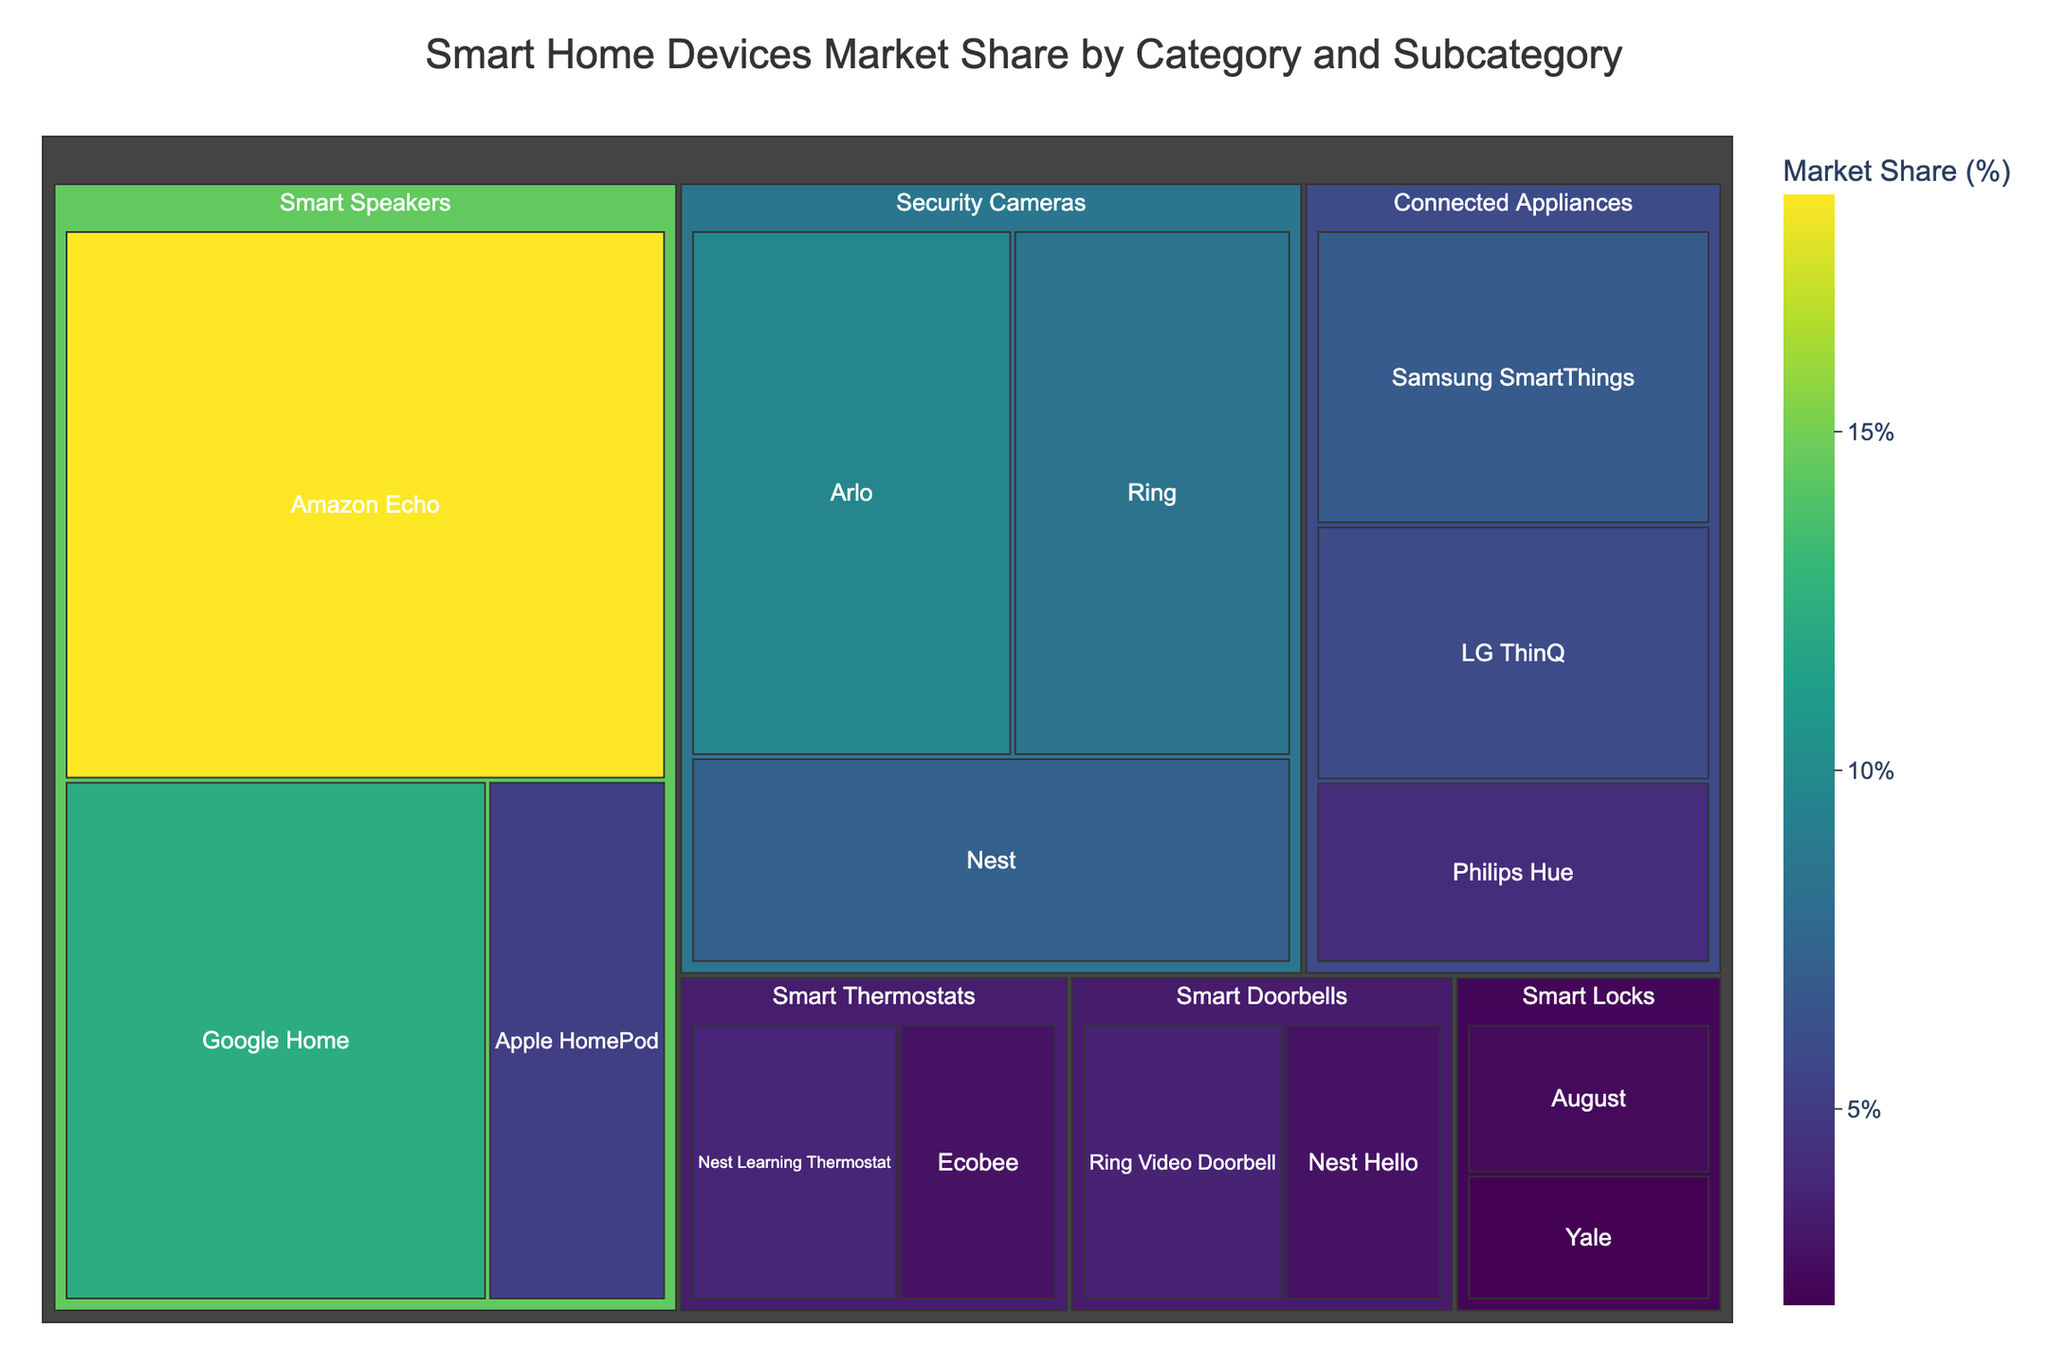What category has the highest market share? To determine which category has the highest market share, we simply look for the largest segment in the treemap. The largest rectangle represents the category with the highest market share.
Answer: Smart Speakers Which subcategory within Security Cameras has the highest market share? Within the Security Cameras category, we examine the subcategories and identify the largest rectangle.
Answer: Arlo What is the combined market share of all connected appliances? Add up the market shares of Samsung SmartThings, LG ThinQ, and Philips Hue. The combined sum is 6.8% + 5.9% + 4.2%.
Answer: 16.9% How does the market share of the Amazon Echo compare to that of Google Home? Look at the market share of Amazon Echo and Google Home and compare the values. Amazon Echo has 18.5%, while Google Home has 12.3%.
Answer: Amazon Echo has a higher market share Which subcategory in Smart Doorbells has the lower market share? Within Smart Doorbells, compare the market shares of Ring Video Doorbell and Nest Hello.
Answer: Nest Hello What is the total market share of the categories that have more than one subcategory listed? Sum the market shares of categories with more than one subcategory: Smart Speakers, Security Cameras, and Connected Appliances. The combined market share is 18.5% + 12.3% + 5.2% + 9.7% + 8.4% + 7.1% + 6.8% + 5.9% + 4.2%.
Answer: 78.1% What's the difference in market share between the Nest Learning Thermostat and Ecobee? Subtract the market share of Ecobee from Nest Learning Thermostat. The difference is 3.8% - 2.9%.
Answer: 0.9% How many subcategories are there in total? Count all the rectangles representing subcategories in the treemap. Each rectangle represents one subcategory.
Answer: 13 Which category has the smallest representation in market share? Identify the smallest rectangle in the treemap.
Answer: Smart Locks What are the market shares of the subcategories in Smart Speakers, in descending order? List the market shares of Amazon Echo, Google Home, and Apple HomePod in descending order.
Answer: 18.5%, 12.3%, 5.2% 